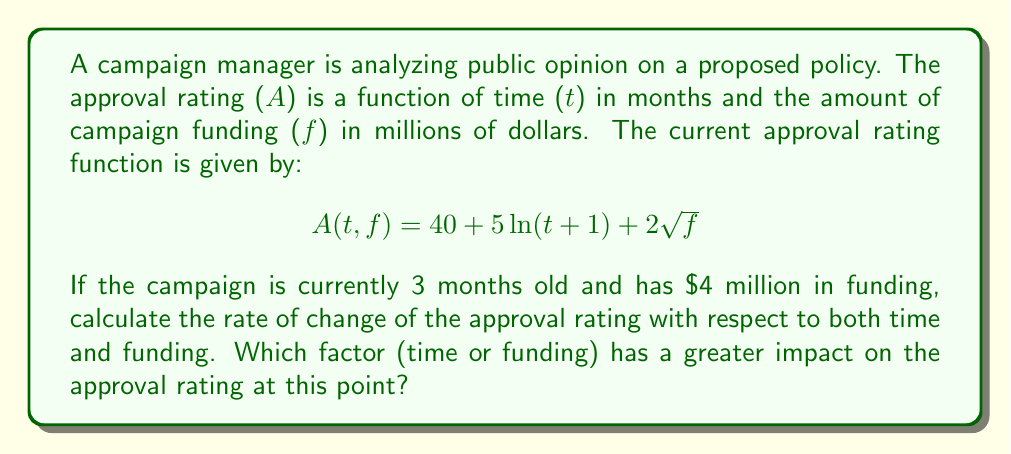Solve this math problem. To solve this problem, we need to use partial derivatives to calculate the rate of change of the approval rating with respect to time and funding separately.

Step 1: Calculate the partial derivative with respect to time (t).
$$\frac{\partial A}{\partial t} = \frac{5}{t+1}$$

Step 2: Calculate the partial derivative with respect to funding (f).
$$\frac{\partial A}{\partial f} = \frac{1}{\sqrt{f}}$$

Step 3: Evaluate the partial derivatives at t = 3 and f = 4.

For time:
$$\frac{\partial A}{\partial t}\bigg|_{t=3} = \frac{5}{3+1} = \frac{5}{4} = 1.25$$

For funding:
$$\frac{\partial A}{\partial f}\bigg|_{f=4} = \frac{1}{\sqrt{4}} = \frac{1}{2} = 0.5$$

Step 4: Compare the two rates of change.
The rate of change with respect to time (1.25) is greater than the rate of change with respect to funding (0.5) at this point.

Therefore, time has a greater impact on the approval rating at this point in the campaign.
Answer: $\frac{\partial A}{\partial t} = 1.25$, $\frac{\partial A}{\partial f} = 0.5$. Time has greater impact. 